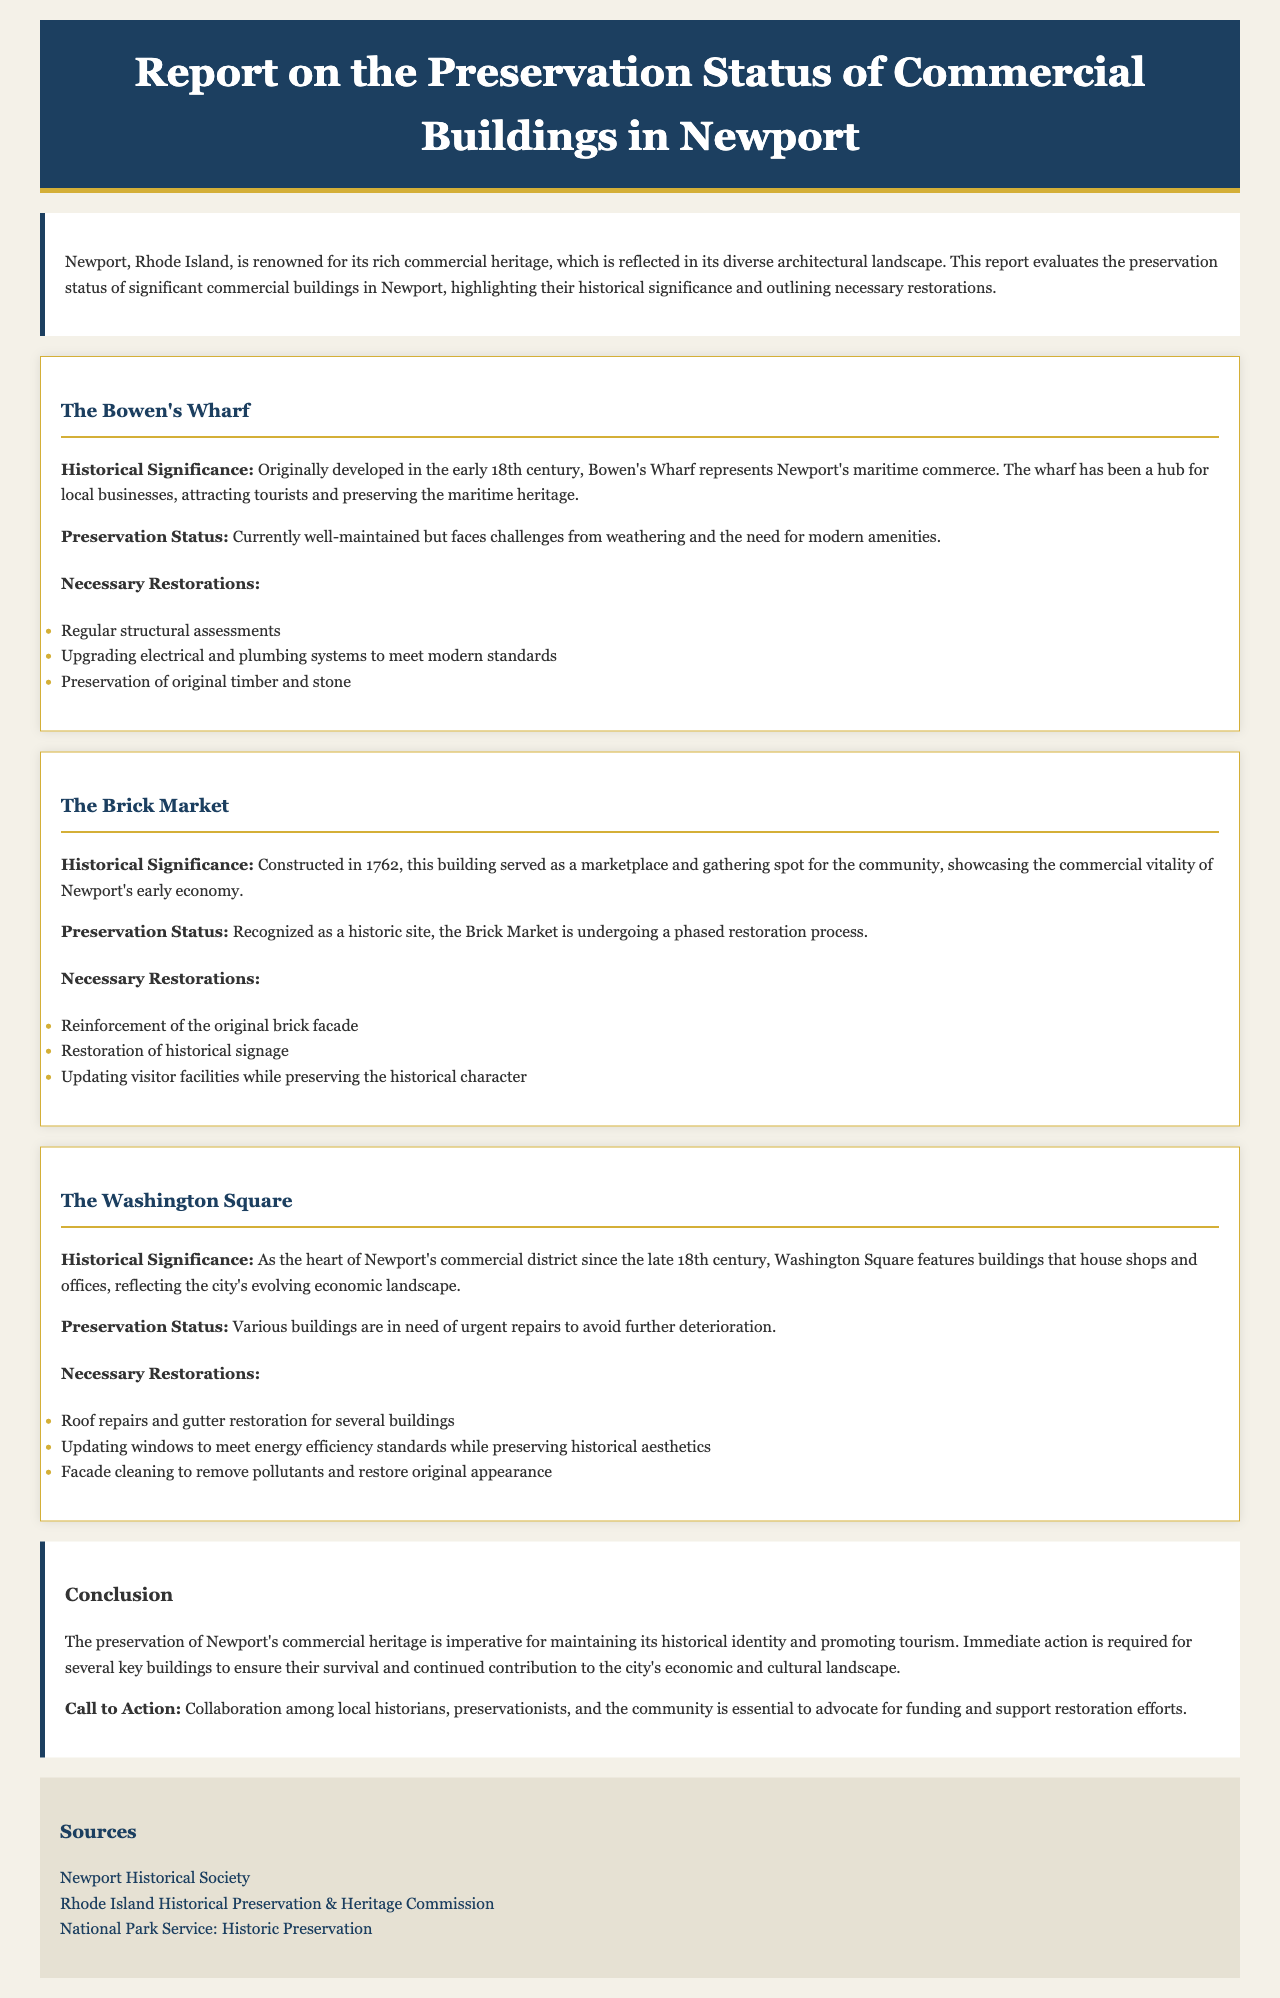What is the name of the historical site constructed in 1762? The Brick Market is mentioned as a significant building constructed in 1762.
Answer: The Brick Market What is the primary focus of the preservation report? The report evaluates the preservation status of significant commercial buildings, detailing their historical significance and restorations needed.
Answer: Preservation status of commercial buildings Which building represents Newport's maritime commerce? Bowen's Wharf is noted for its representation of Newport's maritime commerce starting from the early 18th century.
Answer: Bowen's Wharf What restoration is necessary for Washington Square? The report highlights the need for roof repairs and gutter restoration for several buildings in Washington Square.
Answer: Roof repairs and gutter restoration How many buildings are mentioned in the report? The report discusses three significant buildings: Bowen's Wharf, The Brick Market, and Washington Square.
Answer: Three What does the report propose as essential for preservation efforts? A call to collaboration among local historians, preservationists, and the community is emphasized for advocating funding and support.
Answer: Collaboration among stakeholders What year was Bowen's Wharf originally developed? The report states that Bowen's Wharf was developed in the early 18th century.
Answer: Early 18th century What is the status of the Brick Market? The Brick Market is recognized as a historic site currently undergoing a phased restoration process.
Answer: Undergoing phased restoration What is the main reason for urgent repairs in Washington Square? The need for urgent repairs is highlighted to avoid further deterioration of several buildings.
Answer: Avoid further deterioration 